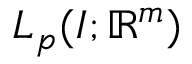Convert formula to latex. <formula><loc_0><loc_0><loc_500><loc_500>L _ { p } ( I ; \mathbb { R } ^ { m } )</formula> 